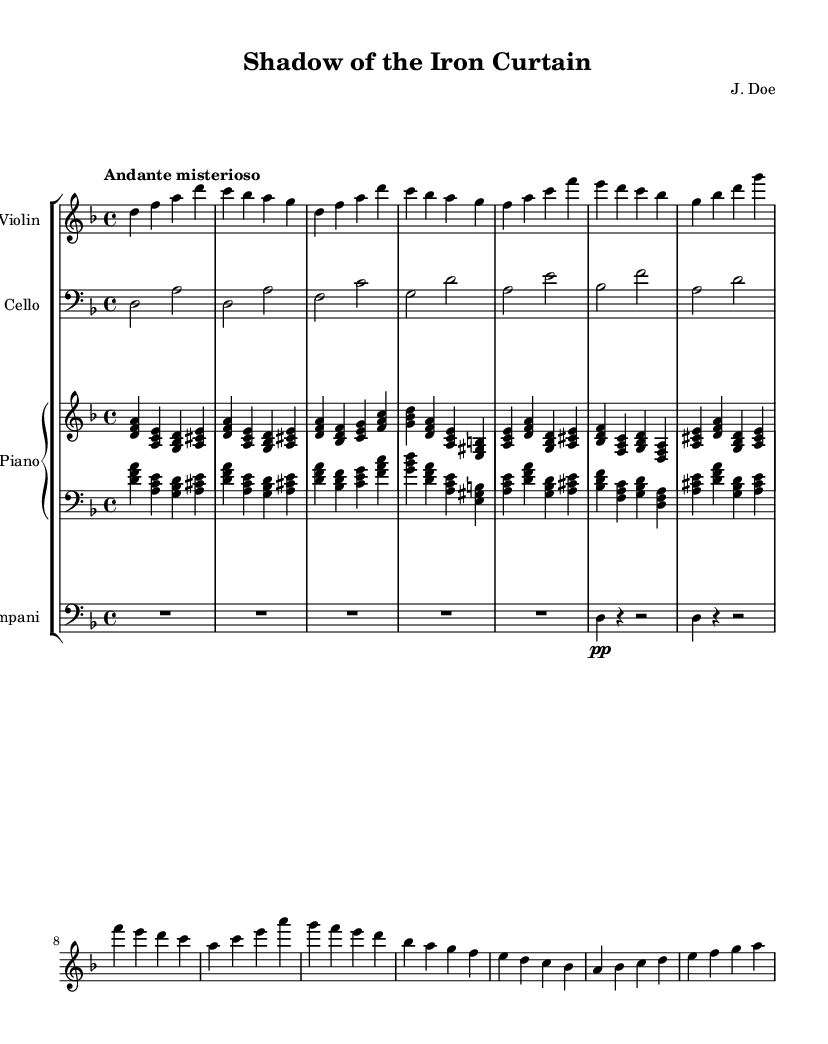What is the key signature of this music? The key signature is indicated in the beginning of the sheet music. In this case, there are two flats, which signifies that the key is D minor.
Answer: D minor What is the time signature of this piece? The time signature is found at the beginning of the sheet music, specifically noted as 4/4, which means there are four beats in a measure.
Answer: 4/4 What tempo is indicated for this piece? The tempo is specified in the tempo marking section of the sheet music. It is described as "Andante misterioso," which indicates a moderately slow and mysterious pace.
Answer: Andante misterioso How many distinct themes are present in the music? The music has two clear themes, labeled as Theme A and Theme B, which can be identified through the labeled sections of the score.
Answer: 2 What instrument plays the introduction? The introduction is presented in the violin part at the start of the sheet music, making it the instrument that begins the piece.
Answer: Violin What is the dynamic marking for the timpani in the bridge section? The dynamic marking for the timpani is indicated in the bridge section, where it shows 'pp' (pianissimo), indicating a very soft sound.
Answer: pianissimo What is the primary mood suggested by the title and instrumentation of this piece? The title "Shadow of the Iron Curtain" and the use of atmospheric instrumental tracks imply a mood of suspense and tension, fitting the theme of espionage.
Answer: Suspense 